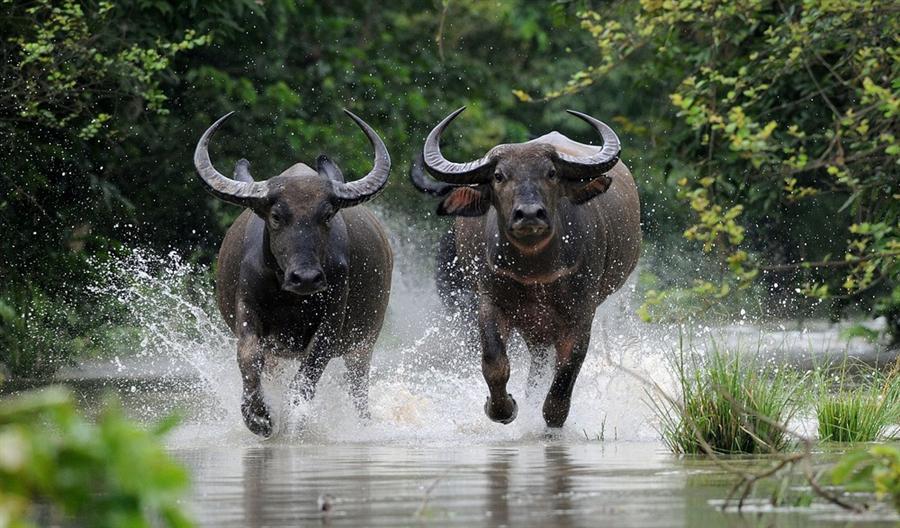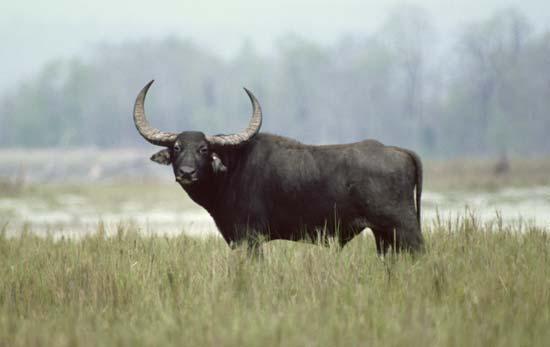The first image is the image on the left, the second image is the image on the right. For the images shown, is this caption "There are no less than two Water Buffalo in one of the images." true? Answer yes or no. Yes. The first image is the image on the left, the second image is the image on the right. Given the left and right images, does the statement "In one image there is a lone water buffalo standing in water." hold true? Answer yes or no. No. 